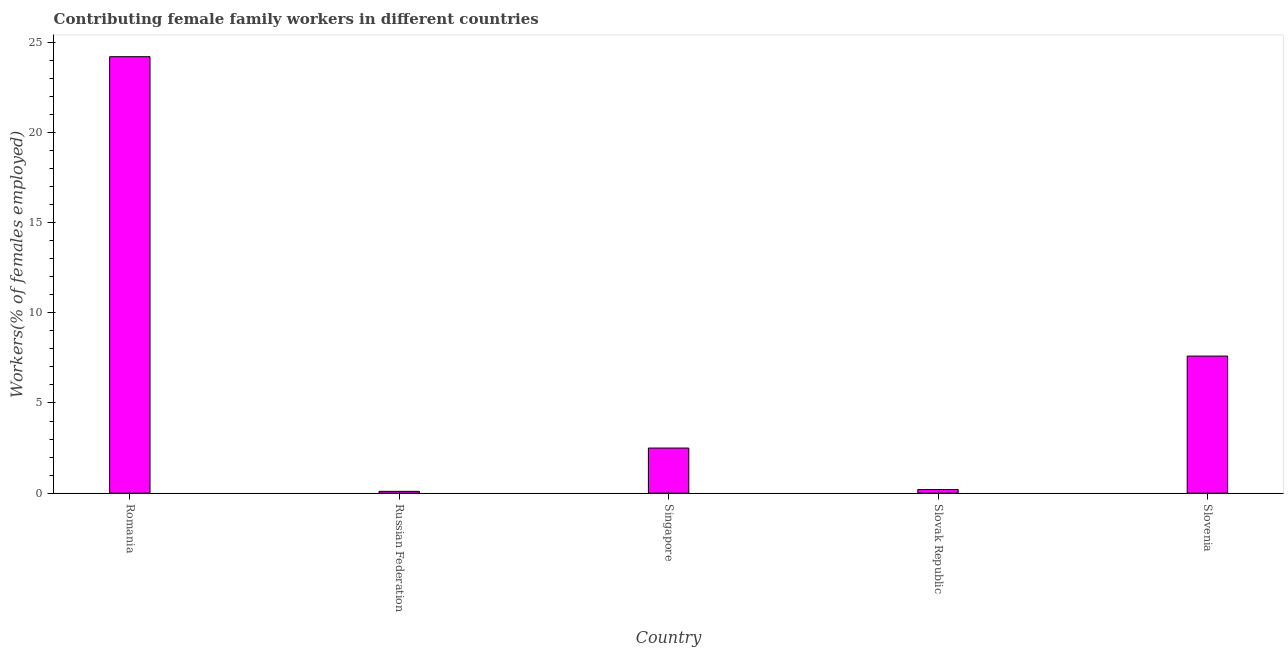Does the graph contain any zero values?
Provide a succinct answer. No. Does the graph contain grids?
Give a very brief answer. No. What is the title of the graph?
Provide a succinct answer. Contributing female family workers in different countries. What is the label or title of the Y-axis?
Ensure brevity in your answer.  Workers(% of females employed). What is the contributing female family workers in Slovenia?
Provide a succinct answer. 7.6. Across all countries, what is the maximum contributing female family workers?
Your answer should be compact. 24.2. Across all countries, what is the minimum contributing female family workers?
Offer a terse response. 0.1. In which country was the contributing female family workers maximum?
Your answer should be very brief. Romania. In which country was the contributing female family workers minimum?
Offer a very short reply. Russian Federation. What is the sum of the contributing female family workers?
Make the answer very short. 34.6. What is the average contributing female family workers per country?
Give a very brief answer. 6.92. What is the median contributing female family workers?
Keep it short and to the point. 2.5. What is the ratio of the contributing female family workers in Singapore to that in Slovenia?
Make the answer very short. 0.33. Is the difference between the contributing female family workers in Romania and Russian Federation greater than the difference between any two countries?
Provide a short and direct response. Yes. What is the difference between the highest and the second highest contributing female family workers?
Make the answer very short. 16.6. Is the sum of the contributing female family workers in Singapore and Slovenia greater than the maximum contributing female family workers across all countries?
Make the answer very short. No. What is the difference between the highest and the lowest contributing female family workers?
Your answer should be very brief. 24.1. In how many countries, is the contributing female family workers greater than the average contributing female family workers taken over all countries?
Provide a short and direct response. 2. Are all the bars in the graph horizontal?
Offer a terse response. No. What is the Workers(% of females employed) of Romania?
Keep it short and to the point. 24.2. What is the Workers(% of females employed) of Russian Federation?
Offer a very short reply. 0.1. What is the Workers(% of females employed) in Slovak Republic?
Ensure brevity in your answer.  0.2. What is the Workers(% of females employed) in Slovenia?
Keep it short and to the point. 7.6. What is the difference between the Workers(% of females employed) in Romania and Russian Federation?
Make the answer very short. 24.1. What is the difference between the Workers(% of females employed) in Romania and Singapore?
Provide a short and direct response. 21.7. What is the difference between the Workers(% of females employed) in Romania and Slovenia?
Ensure brevity in your answer.  16.6. What is the difference between the Workers(% of females employed) in Russian Federation and Slovak Republic?
Provide a short and direct response. -0.1. What is the difference between the Workers(% of females employed) in Singapore and Slovenia?
Provide a short and direct response. -5.1. What is the ratio of the Workers(% of females employed) in Romania to that in Russian Federation?
Give a very brief answer. 242. What is the ratio of the Workers(% of females employed) in Romania to that in Singapore?
Your response must be concise. 9.68. What is the ratio of the Workers(% of females employed) in Romania to that in Slovak Republic?
Ensure brevity in your answer.  121. What is the ratio of the Workers(% of females employed) in Romania to that in Slovenia?
Offer a very short reply. 3.18. What is the ratio of the Workers(% of females employed) in Russian Federation to that in Singapore?
Offer a very short reply. 0.04. What is the ratio of the Workers(% of females employed) in Russian Federation to that in Slovenia?
Provide a succinct answer. 0.01. What is the ratio of the Workers(% of females employed) in Singapore to that in Slovenia?
Keep it short and to the point. 0.33. What is the ratio of the Workers(% of females employed) in Slovak Republic to that in Slovenia?
Your response must be concise. 0.03. 